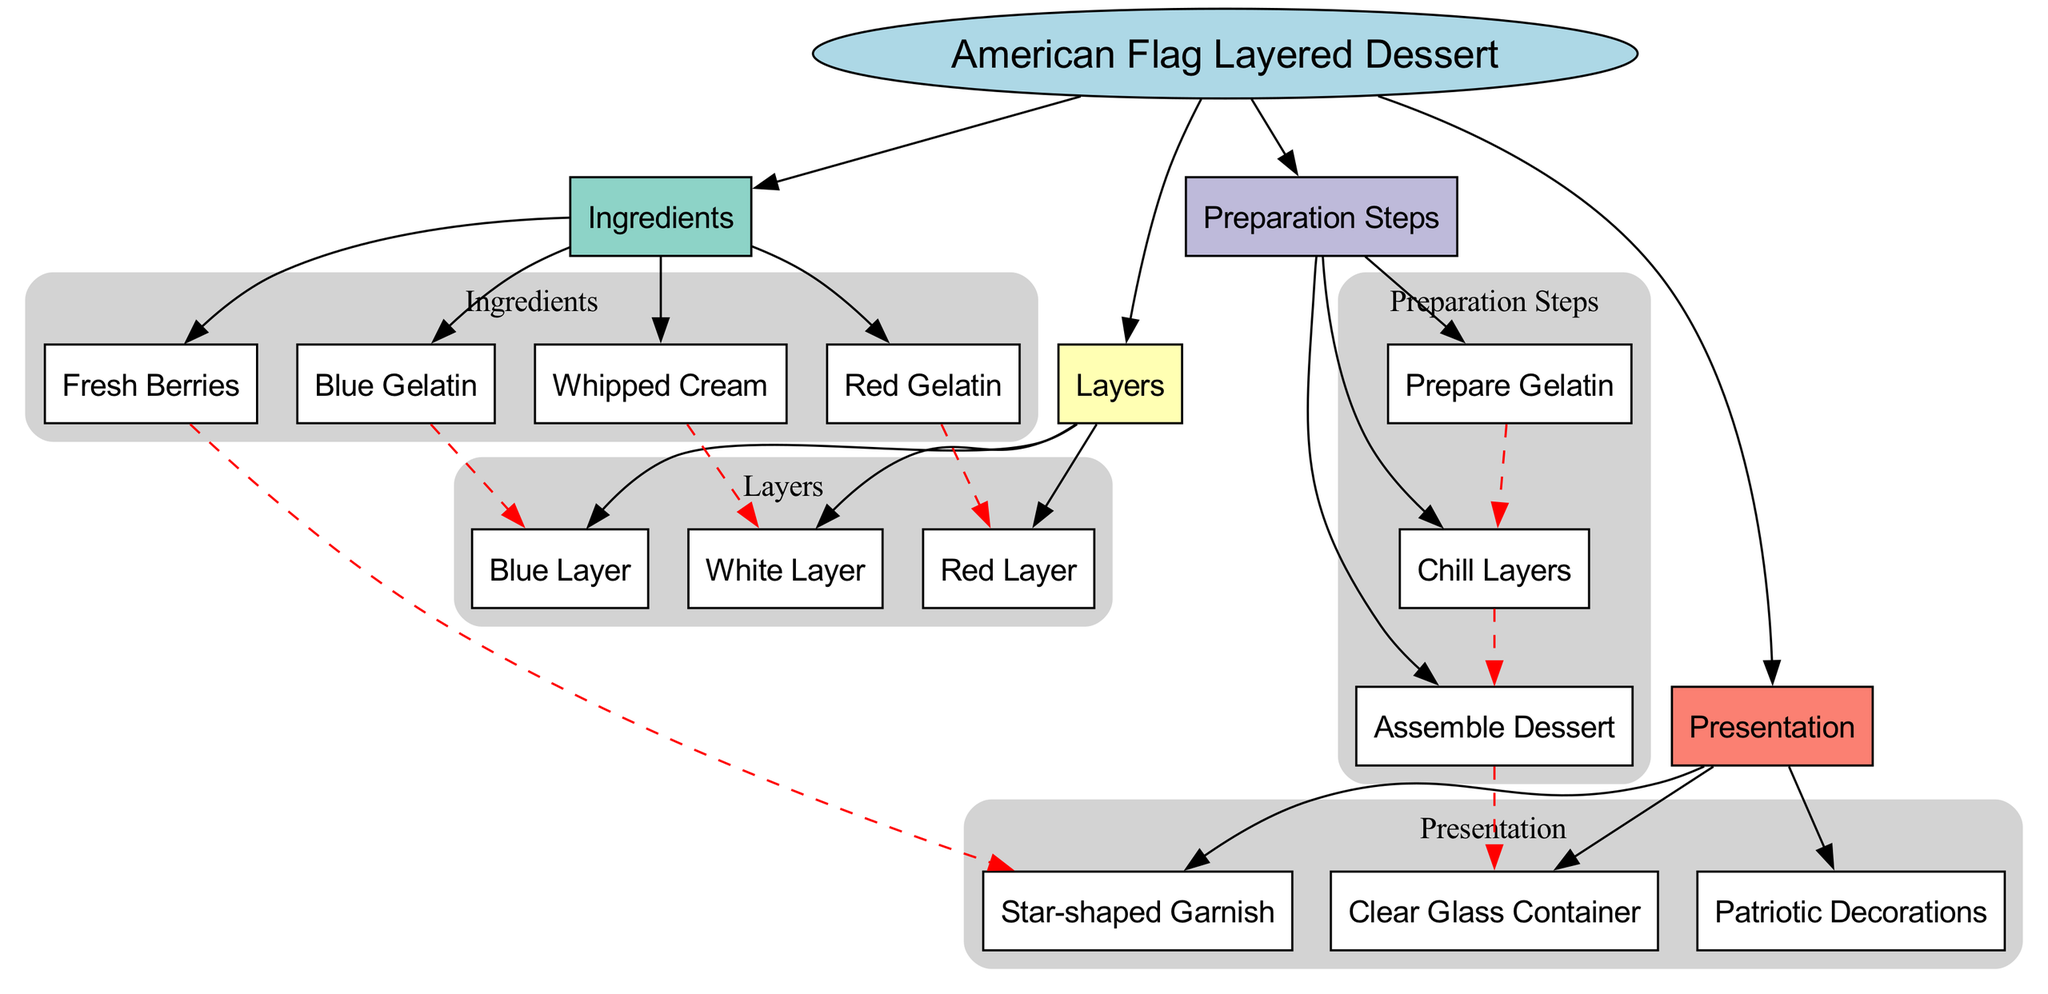What are the main nodes in the concept map? The main nodes listed in the concept map are Ingredients, Layers, Preparation Steps, and Presentation. This information can be found directly connected to the central concept, American Flag Layered Dessert.
Answer: Ingredients, Layers, Preparation Steps, Presentation How many ingredients are listed in the diagram? The diagram shows four ingredients: Red Gelatin, Blue Gelatin, Whipped Cream, and Fresh Berries. Counting these ingredients provides the total.
Answer: 4 Which ingredient is used for the white layer? Whipped Cream is specifically indicated as the ingredient that corresponds to the White Layer in the preparation of the dessert. This direct connection can be seen in the diagram.
Answer: Whipped Cream What is the first step in preparing the dessert? The first preparation step is Prepare Gelatin, as indicated in the Preparation Steps section, which is the initial action in assembling the dessert layers.
Answer: Prepare Gelatin Which layer corresponds to Blue Gelatin? The Blue Layer is linked directly to Blue Gelatin in the diagram, showing that this gelatin is the key ingredient for creating the blue-colored portion of the dessert.
Answer: Blue Layer What happens after chilling the layers? After Chilling Layers, the next step is to Assemble Dessert, showing the sequential flow of actions in the preparation process. This indicates what follows after chilling the layers.
Answer: Assemble Dessert How is the dessert presented? The presentation includes a Clear Glass Container, Star-shaped Garnish, and Patriotic Decorations as its primary components, which can be seen in the Presentation section of the diagram.
Answer: Clear Glass Container, Star-shaped Garnish, Patriotic Decorations Which sub-node is connected to Fresh Berries? Fresh Berries are connected to the Star-shaped Garnish, indicating that they are used to create a decorative element for the dessert, as shown in the relationships within the concept map.
Answer: Star-shaped Garnish What is one connection between components? One specific connection is from Red Gelatin to Red Layer, indicating that red gelatin is used to form the red-colored layer of the dessert. This relationship clearly shows how each ingredient is applied.
Answer: Red Gelatin to Red Layer 